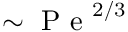<formula> <loc_0><loc_0><loc_500><loc_500>\sim P e ^ { 2 / 3 }</formula> 